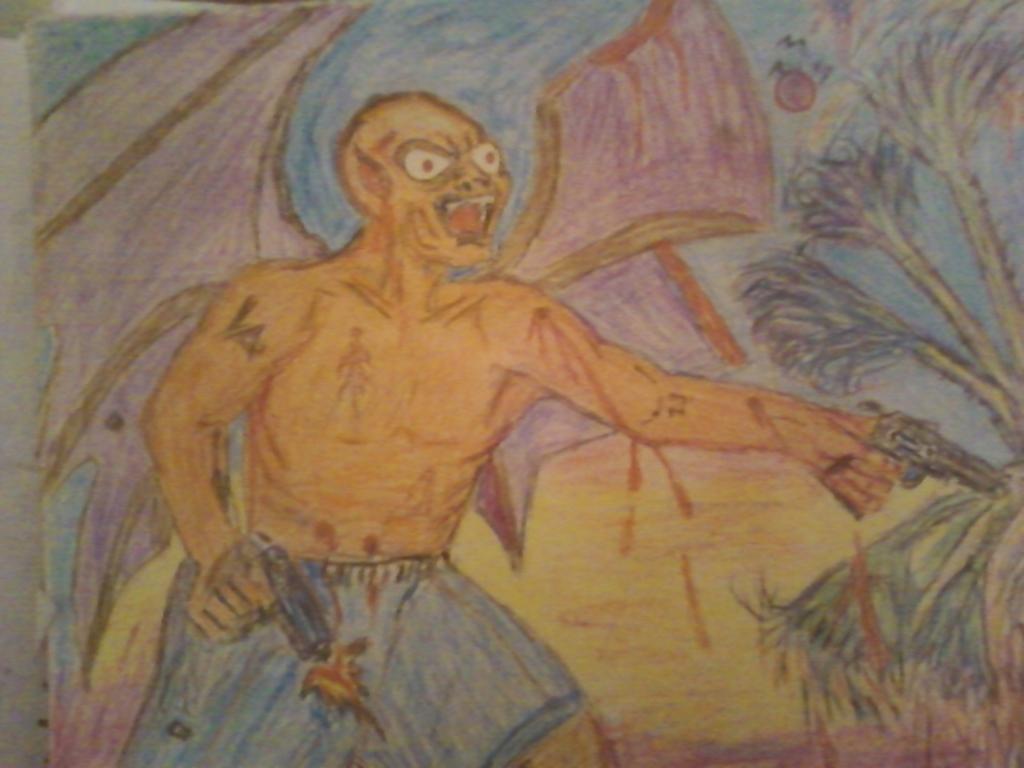Can you describe this image briefly? This picture is a painting. In this image there is a painting of a person standing and holding the guns. On the right side of the image there are trees. At the top there is sky, sun and there are birds. At the bottom there is grass. 